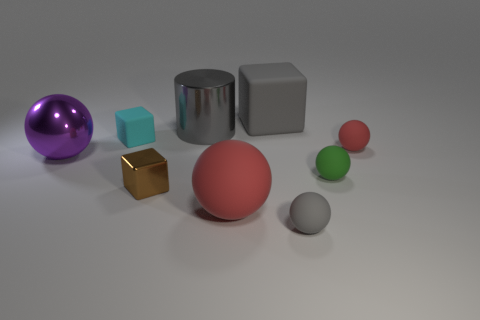Subtract all brown balls. Subtract all red cylinders. How many balls are left? 5 Add 1 red objects. How many objects exist? 10 Subtract all cylinders. How many objects are left? 8 Add 4 gray matte blocks. How many gray matte blocks are left? 5 Add 3 metallic blocks. How many metallic blocks exist? 4 Subtract 0 yellow blocks. How many objects are left? 9 Subtract all small rubber things. Subtract all gray matte cubes. How many objects are left? 4 